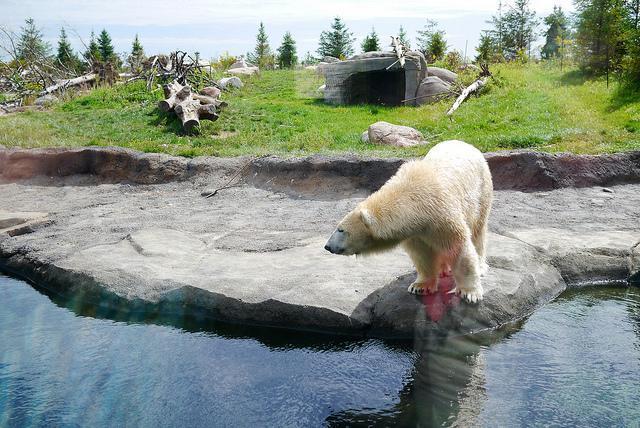How many levels doe the bus have?
Give a very brief answer. 0. 